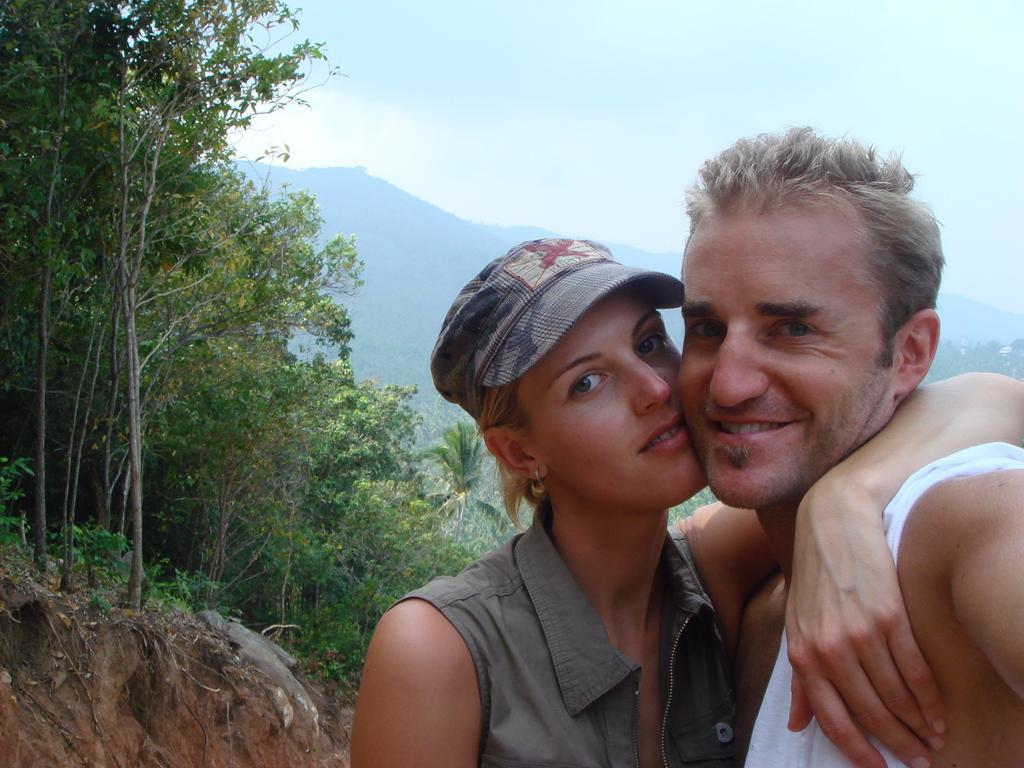In one or two sentences, can you explain what this image depicts? In this image, at the right side there is a man and a woman standing, the woman is wearing a hat, at the left side there are some green color trees, at the top there is a blue color sky. 